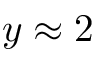<formula> <loc_0><loc_0><loc_500><loc_500>y \approx 2</formula> 